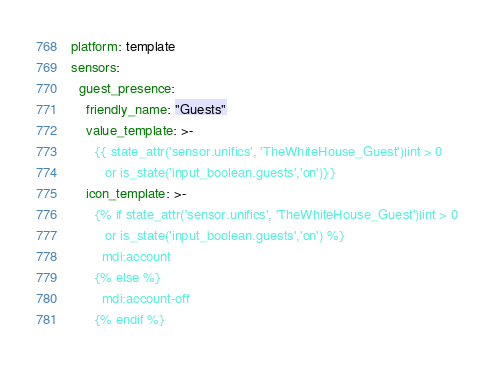<code> <loc_0><loc_0><loc_500><loc_500><_YAML_>platform: template
sensors:
  guest_presence:
    friendly_name: "Guests"
    value_template: >-
      {{ state_attr('sensor.unifics', 'TheWhiteHouse_Guest')|int > 0 
         or is_state('input_boolean.guests','on')}}
    icon_template: >-
      {% if state_attr('sensor.unifics', 'TheWhiteHouse_Guest')|int > 0
         or is_state('input_boolean.guests','on') %}
        mdi:account
      {% else %}
        mdi:account-off
      {% endif %}
</code> 